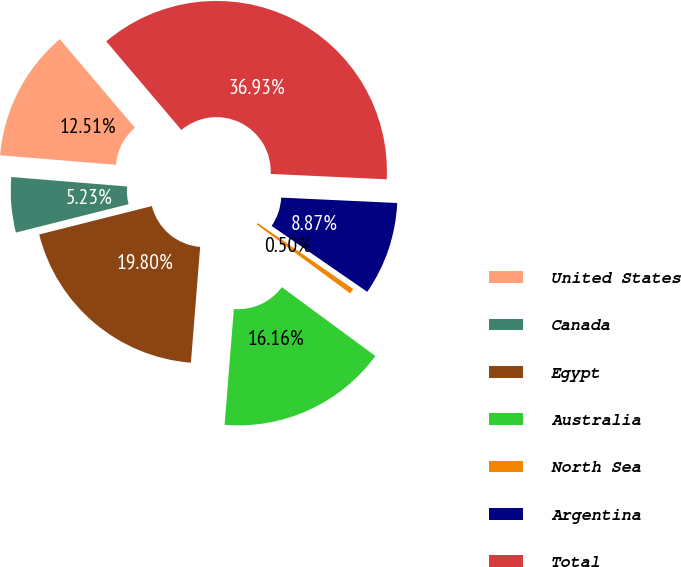Convert chart to OTSL. <chart><loc_0><loc_0><loc_500><loc_500><pie_chart><fcel>United States<fcel>Canada<fcel>Egypt<fcel>Australia<fcel>North Sea<fcel>Argentina<fcel>Total<nl><fcel>12.51%<fcel>5.23%<fcel>19.8%<fcel>16.16%<fcel>0.5%<fcel>8.87%<fcel>36.93%<nl></chart> 